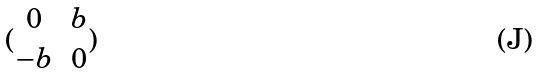Convert formula to latex. <formula><loc_0><loc_0><loc_500><loc_500>( \begin{matrix} 0 & b \\ - b & 0 \end{matrix} )</formula> 